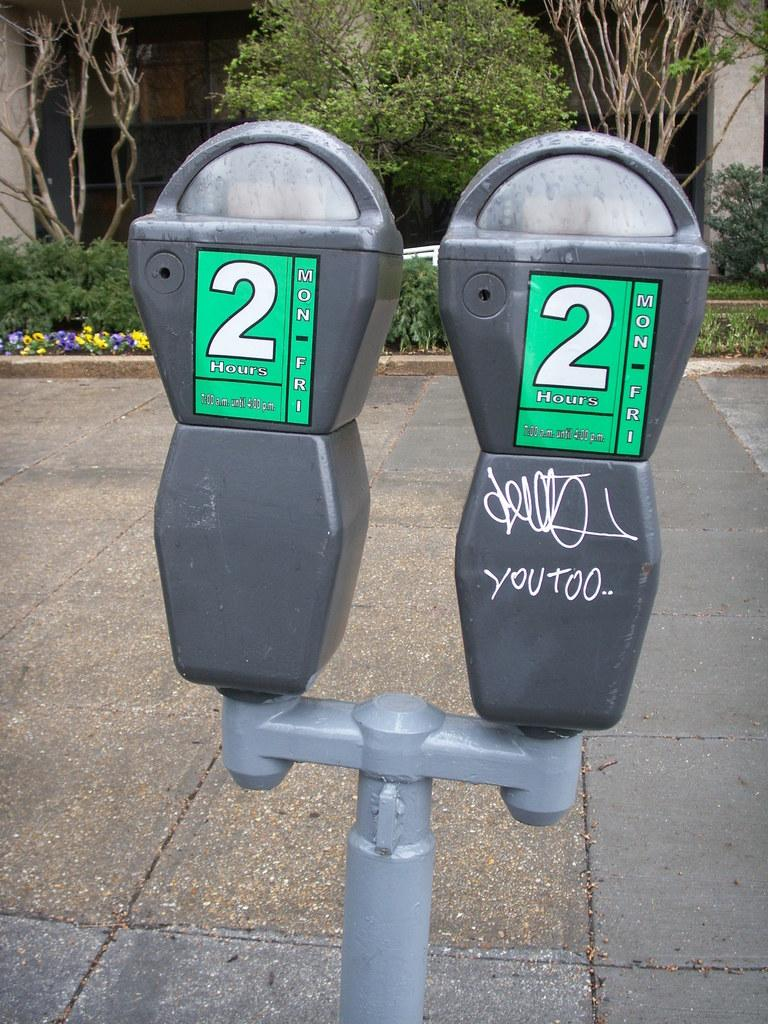<image>
Share a concise interpretation of the image provided. Two parking meter with the number "2" on them 